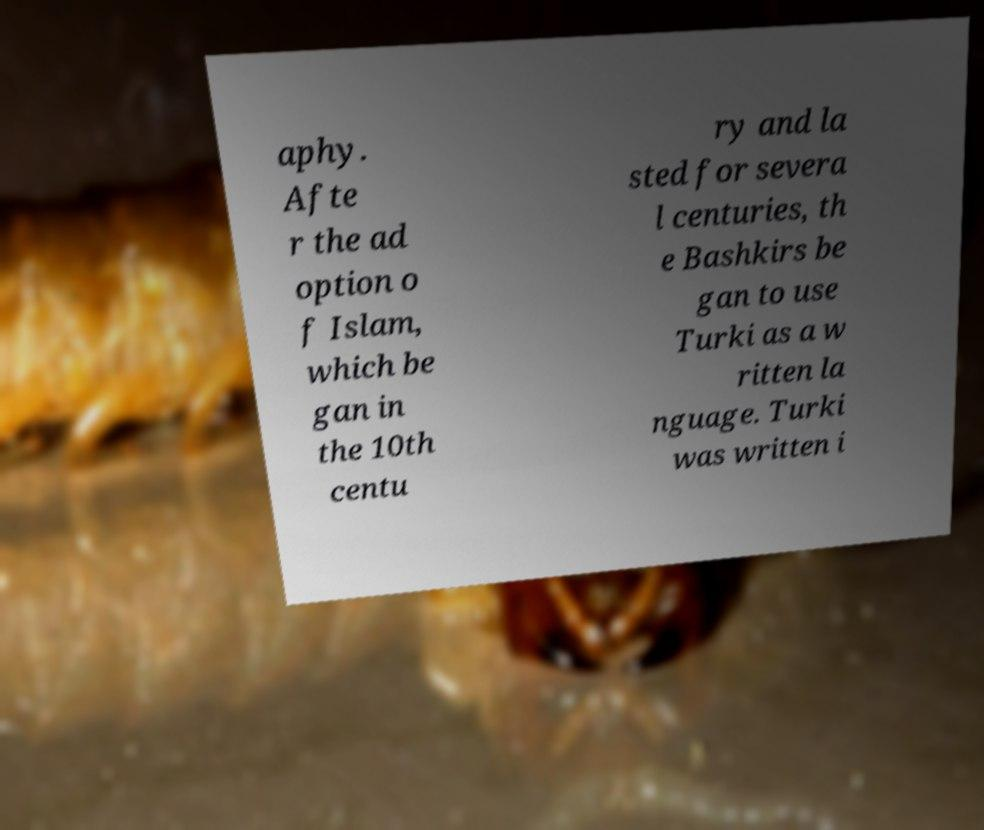What messages or text are displayed in this image? I need them in a readable, typed format. aphy. Afte r the ad option o f Islam, which be gan in the 10th centu ry and la sted for severa l centuries, th e Bashkirs be gan to use Turki as a w ritten la nguage. Turki was written i 